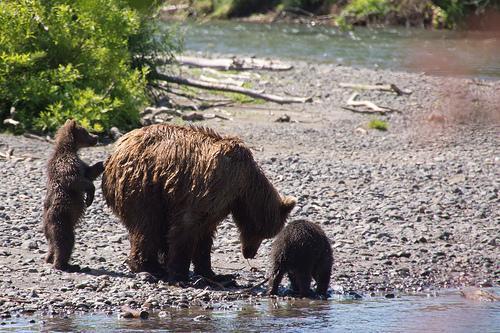How many baby bears are in the picture?
Give a very brief answer. 2. How many big bear are there in the image?
Give a very brief answer. 1. 